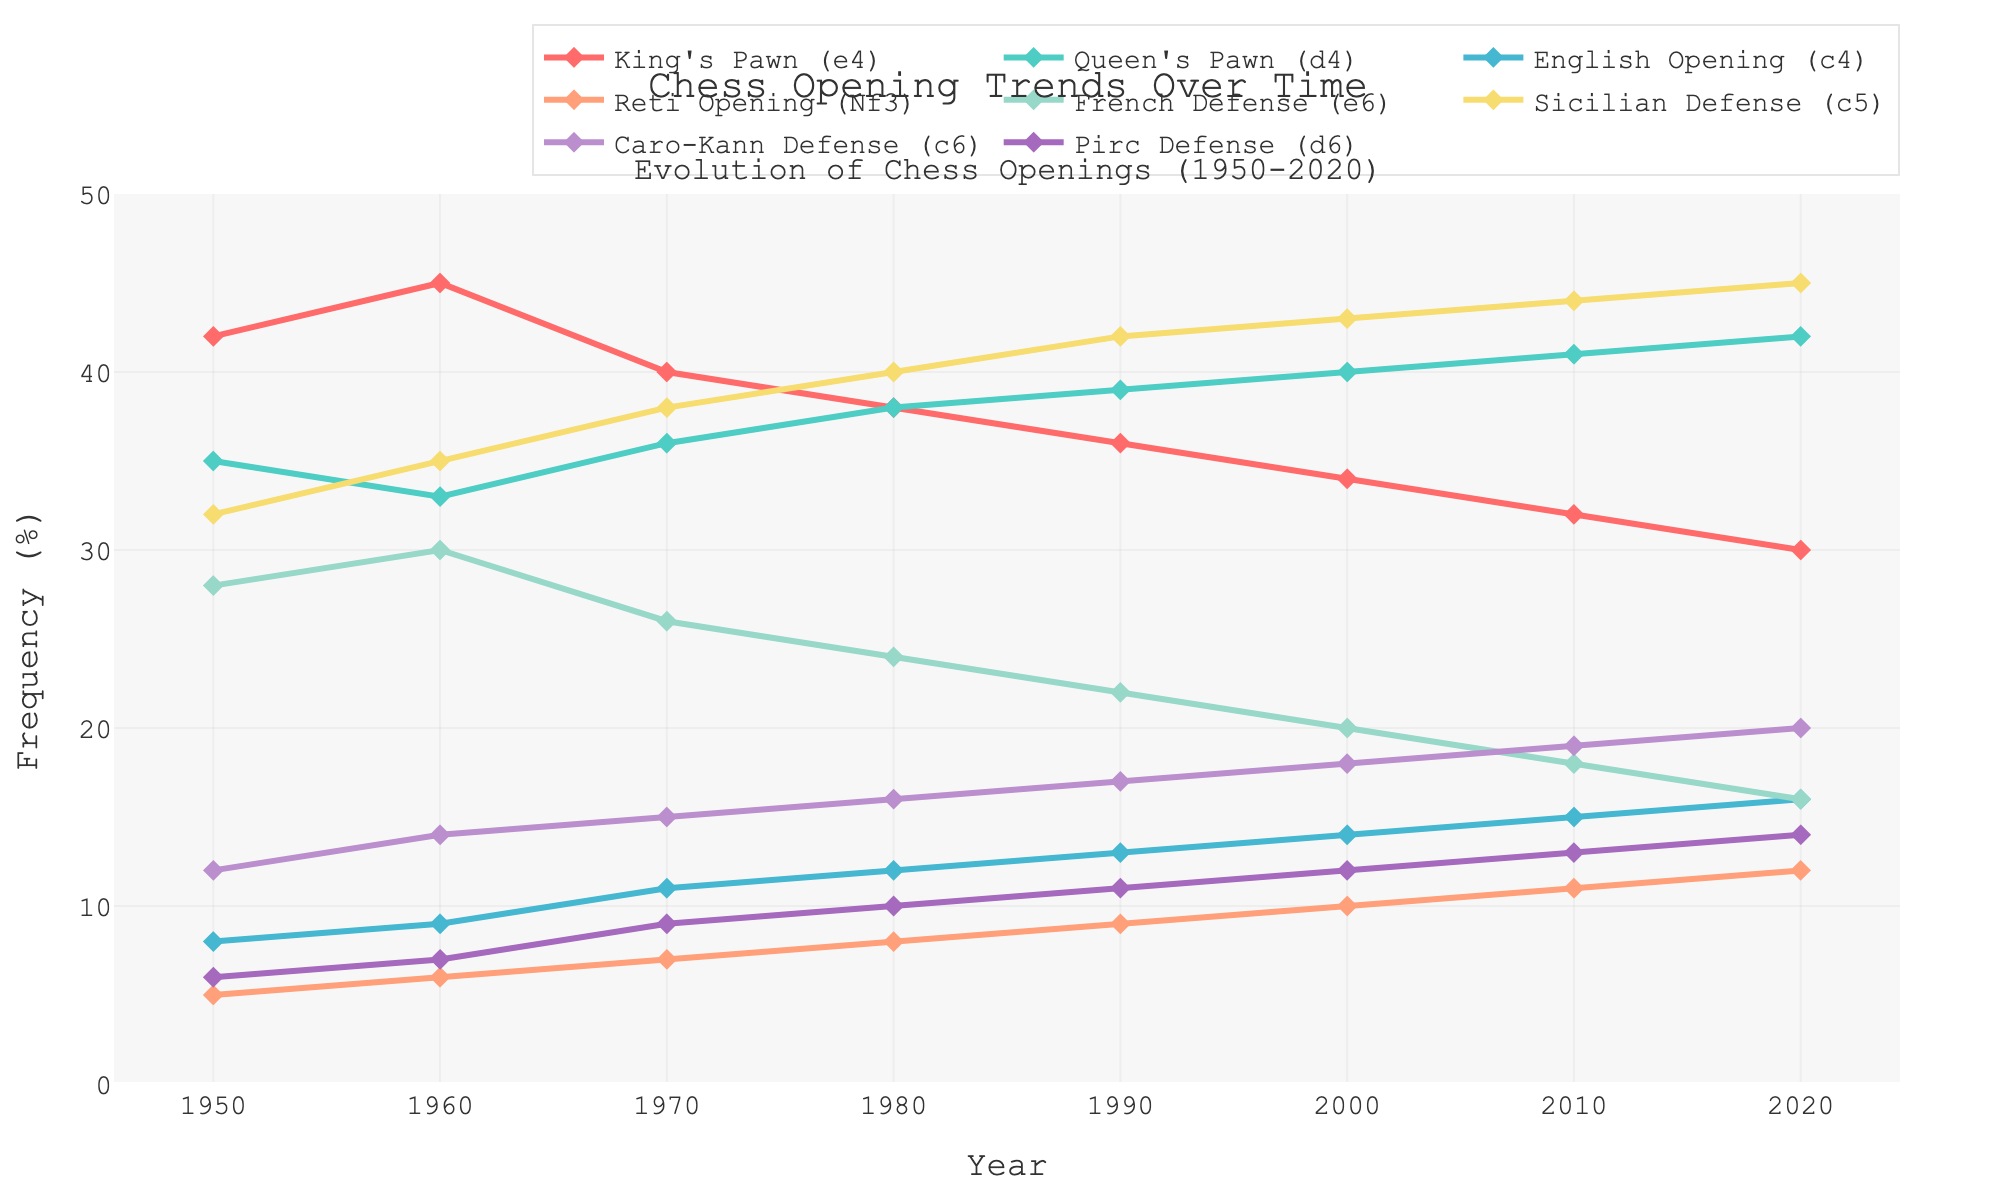What is the general trend for the King's Pawn (e4) from 1950 to 2020? The frequency of the King's Pawn (e4) gradually decreases from 42% in 1950 to 30% in 2020, showing a declining trend over the years.
Answer: Declining Between which years did the Sicilian Defense (c5) see the most significant rise in frequency? From 1950 to 2020, the frequency of the Sicilian Defense (c5) steadily increases. However, the most significant rise is from 1950 (32%) to 1960 (35%) and continues a notable increase until 1980 (40%).
Answer: 1950 to 1980 How does the frequency of the French Defense (e6) in 2000 compare to its frequency in 1950? In 1950, the frequency of the French Defense (e6) is 28%, which decreases to 20% in 2000, indicating a decline.
Answer: Decrease What is the combined frequency of English Opening (c4) and Reti Opening (Nf3) in the year 1980? The frequency of the English Opening (c4) in 1980 is 12%, and the Reti Opening (Nf3) is 8%. Their combined frequency is 12% + 8% = 20%.
Answer: 20% Which opening had the highest frequency increase between 1950 and 2020? The Sicilian Defense (c5) had the frequency increase from 32% in 1950 to 45% in 2020, which is the most significant increase.
Answer: Sicilian Defense (c5) During which decade did the Queen's Pawn (d4) surpass King's Pawn (e4) in frequency? The Queen's Pawn (d4) surpassed King's Pawn (e4) in frequency in the decade between 1970 (d4: 36%, e4: 40%) and 1980 (d4: 38%, e4: 38%). It happened specifically in 1980 when both had equal frequencies before d4 took the lead.
Answer: 1980 Which opening has the least variation in frequency over the years? The Reti Opening (Nf3) has the least variation in frequency over the years. It ranges from 5% in 1950 to 12% in 2020 with gradual increments.
Answer: Reti Opening (Nf3) What is the percentage difference between the Pirc Defense (d6) in 1990 and 2020? The Pirc Defense (d6) increases from 11% in 1990 to 14% in 2020. The percentage difference is 14% - 11% = 3%.
Answer: 3% 